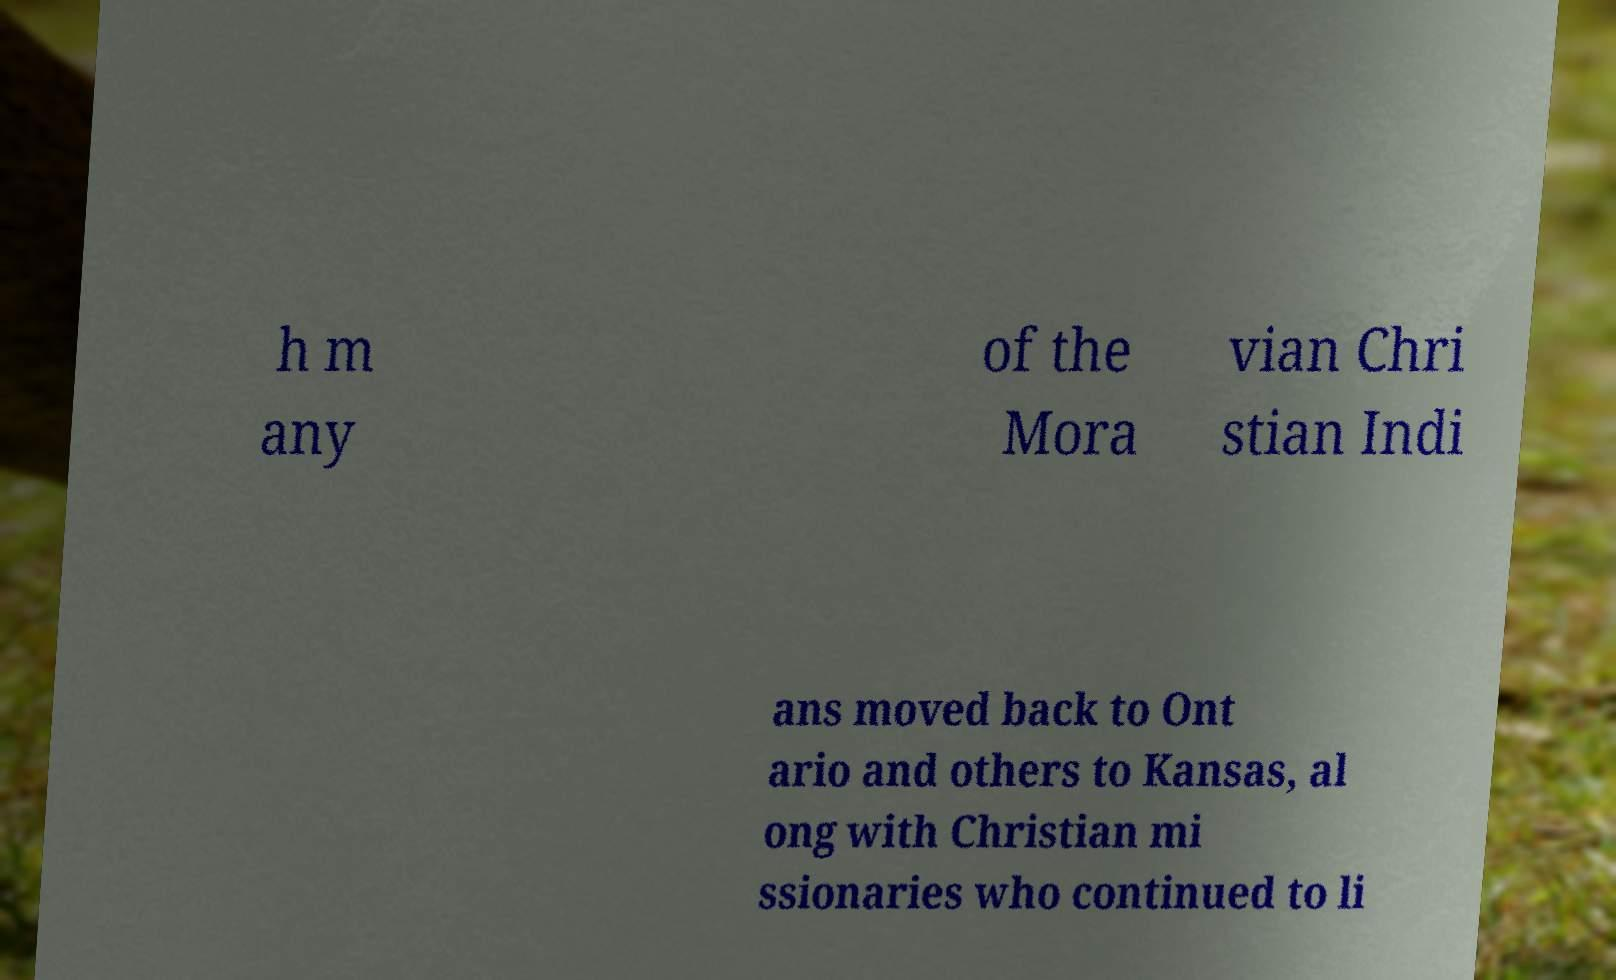Can you accurately transcribe the text from the provided image for me? h m any of the Mora vian Chri stian Indi ans moved back to Ont ario and others to Kansas, al ong with Christian mi ssionaries who continued to li 